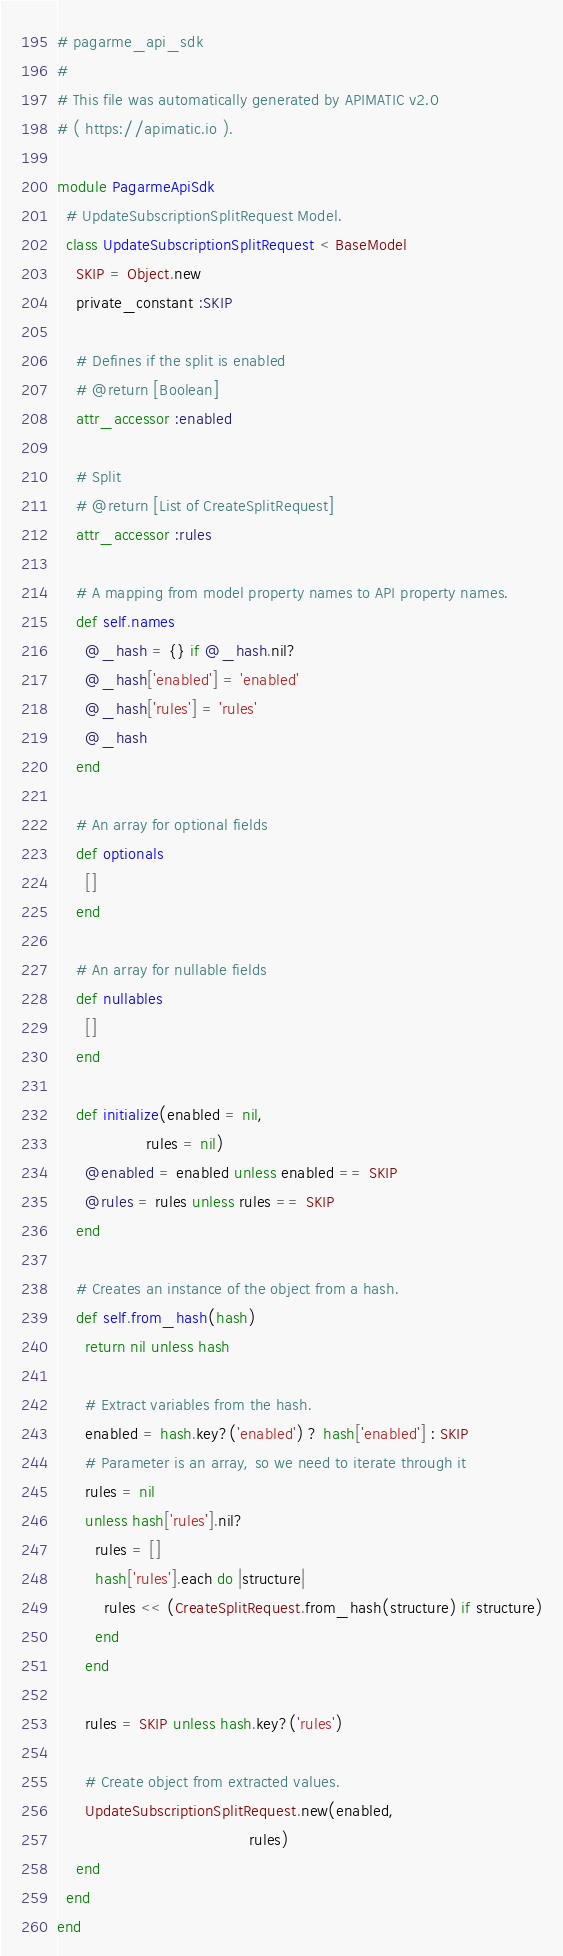<code> <loc_0><loc_0><loc_500><loc_500><_Ruby_># pagarme_api_sdk
#
# This file was automatically generated by APIMATIC v2.0
# ( https://apimatic.io ).

module PagarmeApiSdk
  # UpdateSubscriptionSplitRequest Model.
  class UpdateSubscriptionSplitRequest < BaseModel
    SKIP = Object.new
    private_constant :SKIP

    # Defines if the split is enabled
    # @return [Boolean]
    attr_accessor :enabled

    # Split
    # @return [List of CreateSplitRequest]
    attr_accessor :rules

    # A mapping from model property names to API property names.
    def self.names
      @_hash = {} if @_hash.nil?
      @_hash['enabled'] = 'enabled'
      @_hash['rules'] = 'rules'
      @_hash
    end

    # An array for optional fields
    def optionals
      []
    end

    # An array for nullable fields
    def nullables
      []
    end

    def initialize(enabled = nil,
                   rules = nil)
      @enabled = enabled unless enabled == SKIP
      @rules = rules unless rules == SKIP
    end

    # Creates an instance of the object from a hash.
    def self.from_hash(hash)
      return nil unless hash

      # Extract variables from the hash.
      enabled = hash.key?('enabled') ? hash['enabled'] : SKIP
      # Parameter is an array, so we need to iterate through it
      rules = nil
      unless hash['rules'].nil?
        rules = []
        hash['rules'].each do |structure|
          rules << (CreateSplitRequest.from_hash(structure) if structure)
        end
      end

      rules = SKIP unless hash.key?('rules')

      # Create object from extracted values.
      UpdateSubscriptionSplitRequest.new(enabled,
                                         rules)
    end
  end
end
</code> 